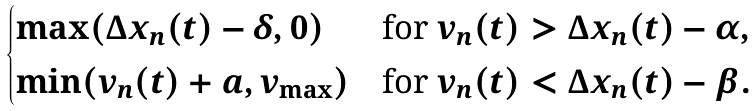Convert formula to latex. <formula><loc_0><loc_0><loc_500><loc_500>\begin{cases} \max ( \Delta x _ { n } ( t ) - \delta , 0 ) & \text {for\ } v _ { n } ( t ) > \Delta x _ { n } ( t ) - \alpha , \\ \min ( v _ { n } ( t ) + a , v _ { \max } ) & \text {for\ } v _ { n } ( t ) < \Delta x _ { n } ( t ) - \beta . \end{cases}</formula> 